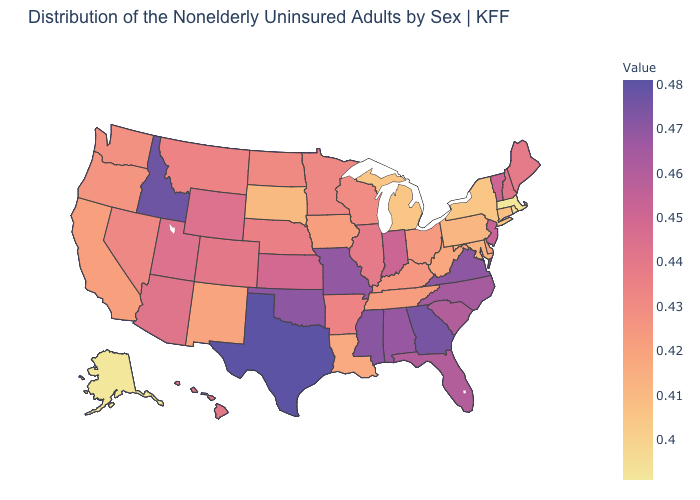Is the legend a continuous bar?
Give a very brief answer. Yes. Which states have the lowest value in the USA?
Be succinct. Alaska, Massachusetts. Among the states that border New Mexico , does Texas have the highest value?
Quick response, please. Yes. Which states have the lowest value in the USA?
Be succinct. Alaska, Massachusetts. 